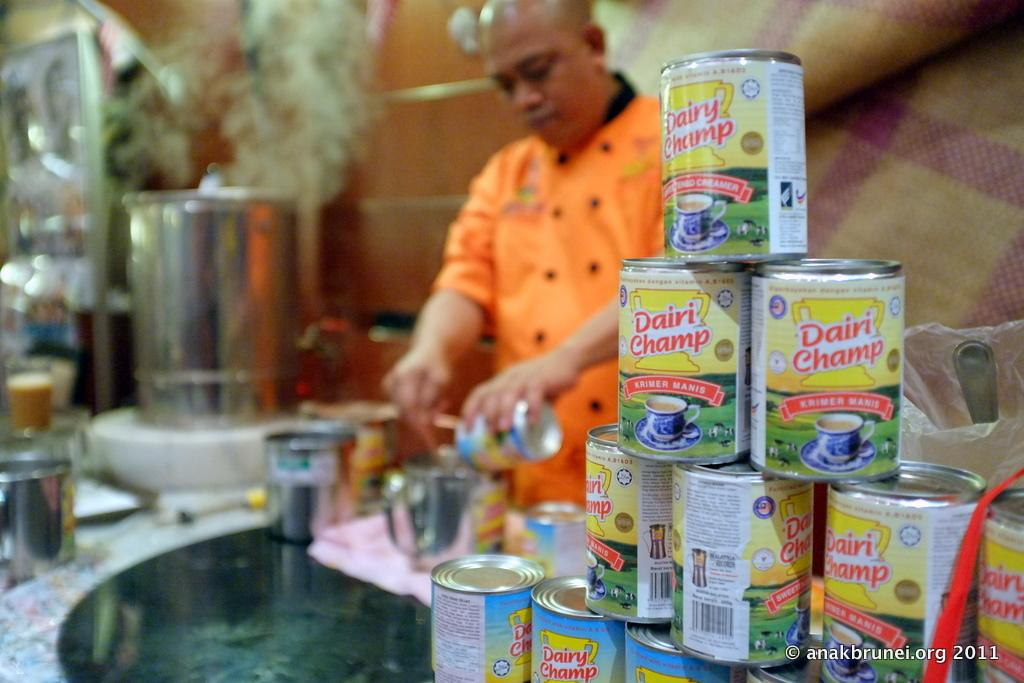What objects are in the foreground of the image? There are sealed bottles in the foreground of the image. Can you describe the person in the image? There is a man in the image. Where is the man positioned in relation to the bottles? The man is behind the bottles. What other items can be seen in the image? There are utensils in the image. What is the man doing in front of the utensils? The man is preparing something in front of the utensils. What year is depicted in the image? The image does not depict a specific year; it is a still image of a man preparing something with utensils and bottles. How many women are present in the image? There are no women present in the image; it features a man behind sealed bottles and in front of utensils. 